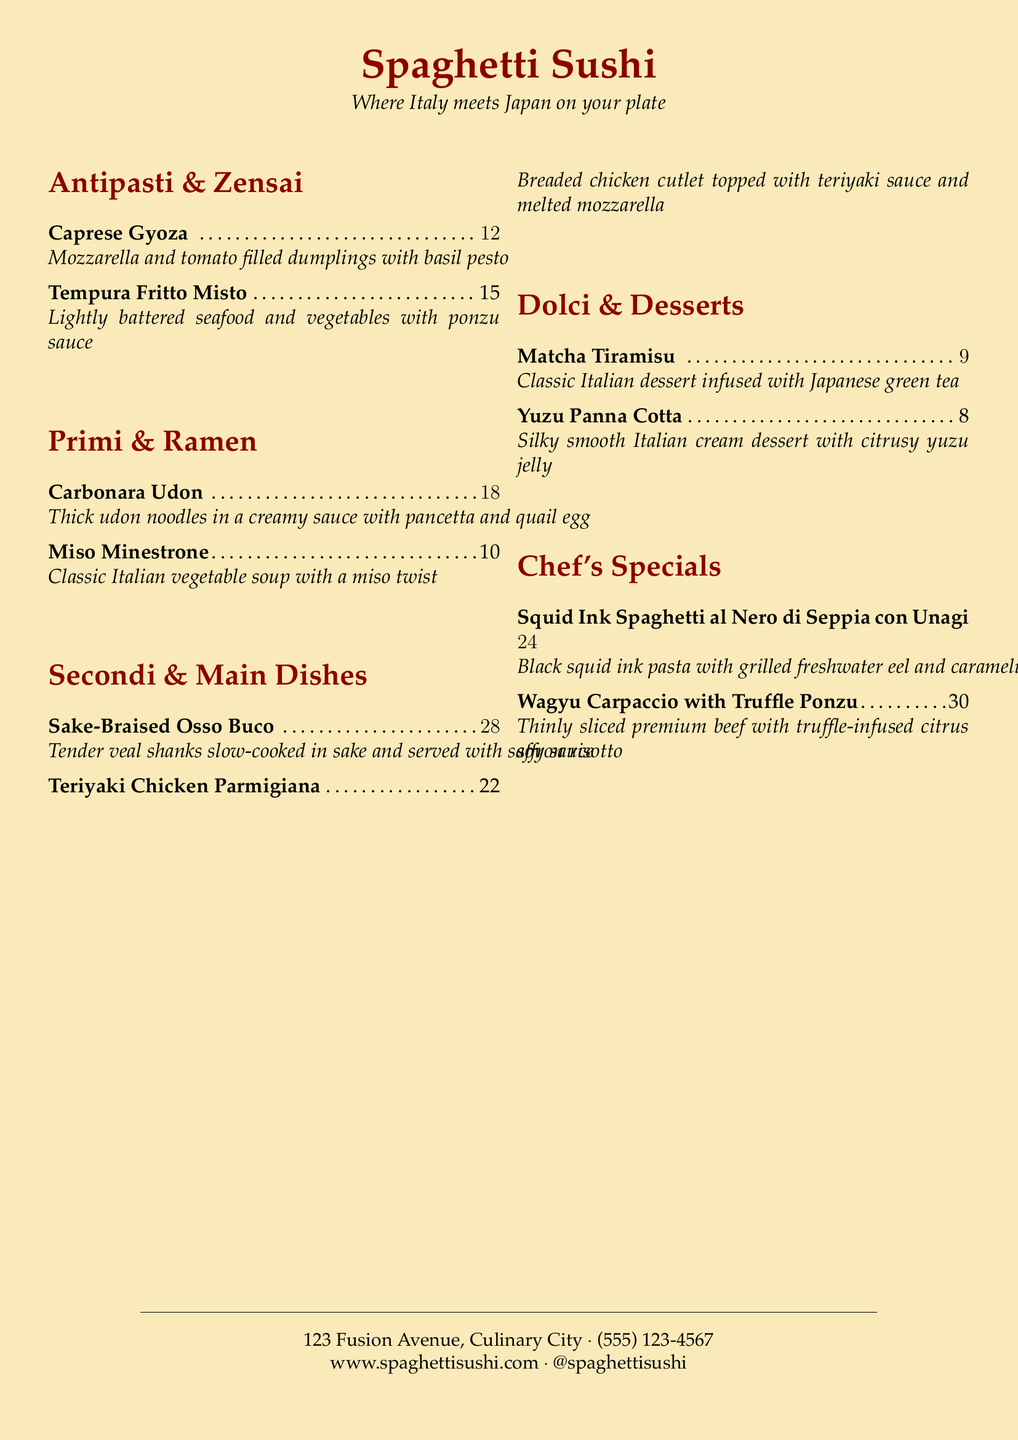What is the price of Caprese Gyoza? The price is listed in the menu beside the item.
Answer: $12 What dish features melted mozzarella? The menu indicates that Teriyaki Chicken Parmigiana includes melted mozzarella as a topping.
Answer: Teriyaki Chicken Parmigiana How many chef's specials are listed? A count of the items in the chef's specials section reveals the total.
Answer: 2 What type of dessert is Matcha Tiramisu? The menu describes it as a classic Italian dessert infused with Japanese green tea.
Answer: Italian dessert What are the main ingredients in the Sake-Braised Osso Buco? The description provides key components of the dish.
Answer: Veal shanks, sake, saffron risotto Which item costs the most? The highest price listed in the menu indicates the most expensive dish.
Answer: Wagyu Carpaccio with Truffle Ponzu What is the theme of the menu? The title and tagline suggest a blending of different cuisines.
Answer: Fusion of Italian and Japanese Is there a vegetable soup on the menu? The presence of Miso Minestrone in the menu indicates a vegetable soup is offered.
Answer: Yes 